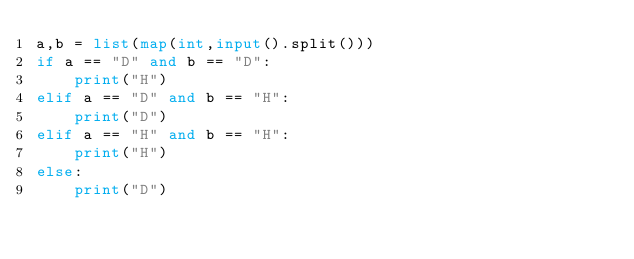<code> <loc_0><loc_0><loc_500><loc_500><_Python_>a,b = list(map(int,input().split()))
if a == "D" and b == "D":
    print("H")
elif a == "D" and b == "H":
    print("D")
elif a == "H" and b == "H":
    print("H")
else:
    print("D")</code> 